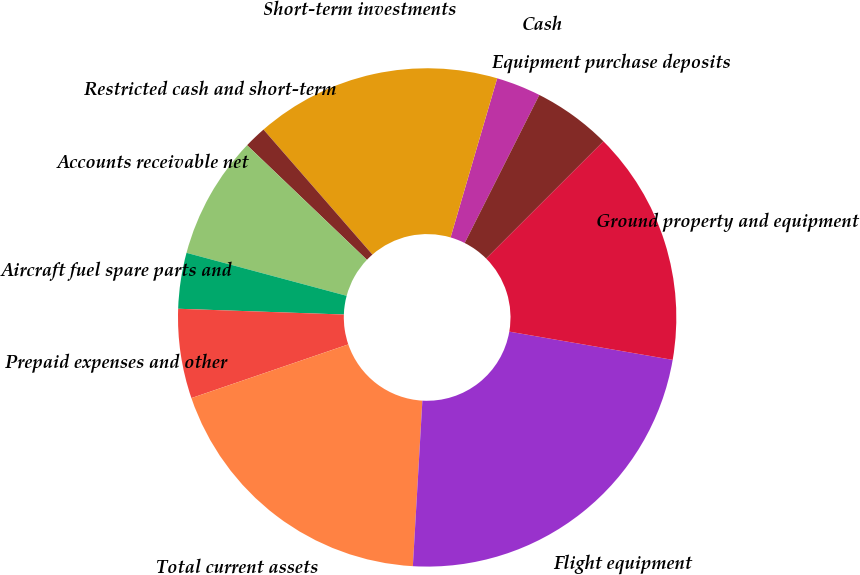<chart> <loc_0><loc_0><loc_500><loc_500><pie_chart><fcel>Cash<fcel>Short-term investments<fcel>Restricted cash and short-term<fcel>Accounts receivable net<fcel>Aircraft fuel spare parts and<fcel>Prepaid expenses and other<fcel>Total current assets<fcel>Flight equipment<fcel>Ground property and equipment<fcel>Equipment purchase deposits<nl><fcel>2.9%<fcel>15.94%<fcel>1.45%<fcel>7.97%<fcel>3.62%<fcel>5.8%<fcel>18.84%<fcel>23.19%<fcel>15.22%<fcel>5.07%<nl></chart> 